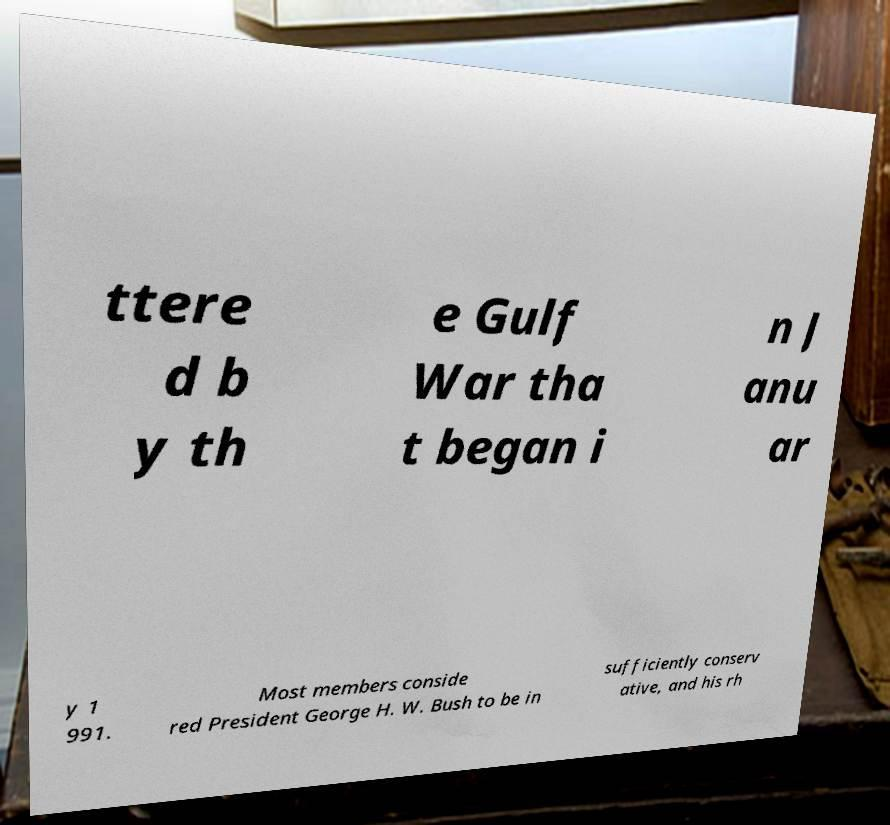Can you read and provide the text displayed in the image?This photo seems to have some interesting text. Can you extract and type it out for me? ttere d b y th e Gulf War tha t began i n J anu ar y 1 991. Most members conside red President George H. W. Bush to be in sufficiently conserv ative, and his rh 